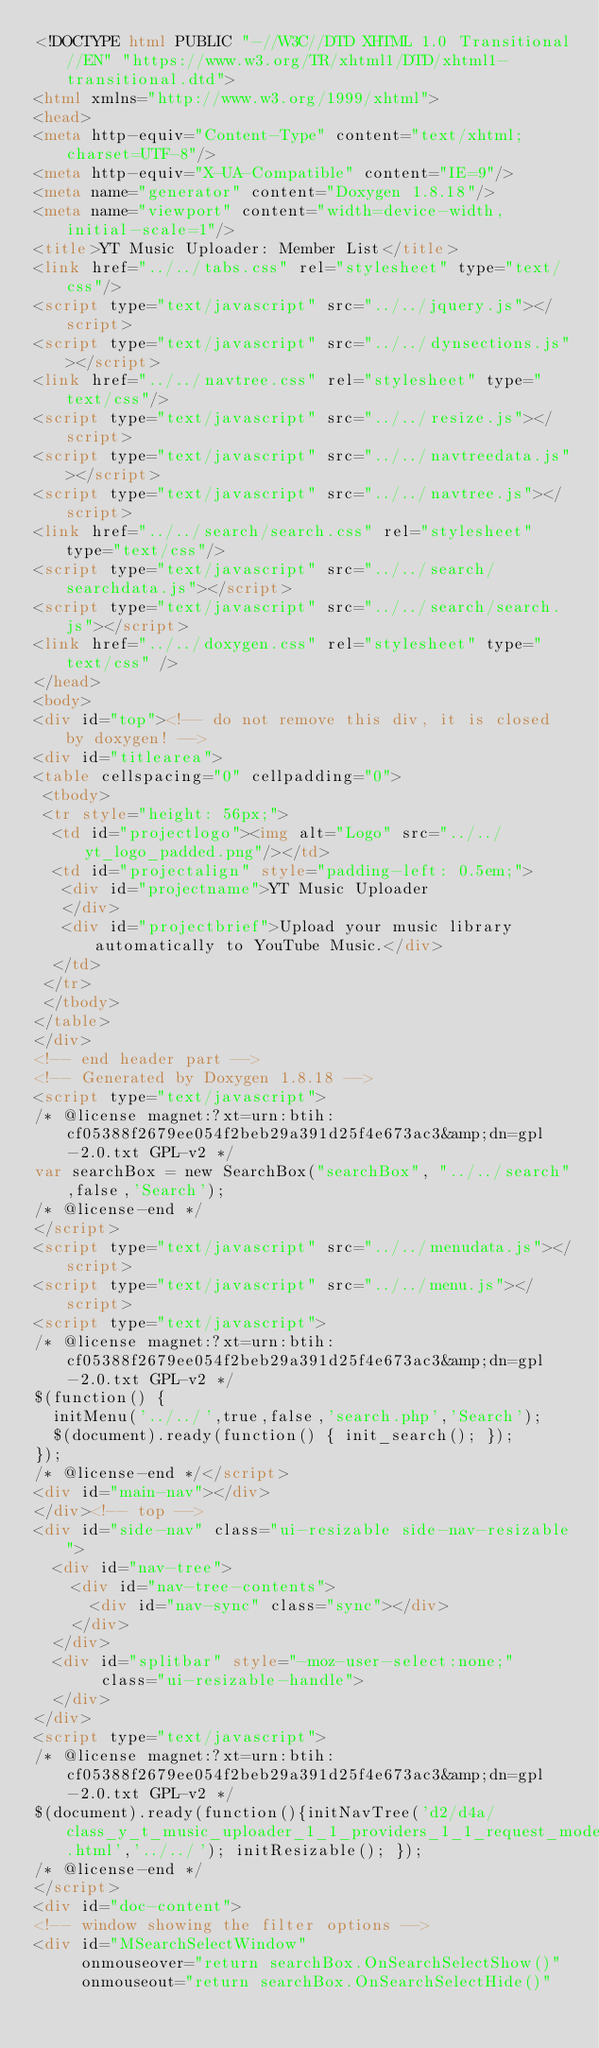Convert code to text. <code><loc_0><loc_0><loc_500><loc_500><_HTML_><!DOCTYPE html PUBLIC "-//W3C//DTD XHTML 1.0 Transitional//EN" "https://www.w3.org/TR/xhtml1/DTD/xhtml1-transitional.dtd">
<html xmlns="http://www.w3.org/1999/xhtml">
<head>
<meta http-equiv="Content-Type" content="text/xhtml;charset=UTF-8"/>
<meta http-equiv="X-UA-Compatible" content="IE=9"/>
<meta name="generator" content="Doxygen 1.8.18"/>
<meta name="viewport" content="width=device-width, initial-scale=1"/>
<title>YT Music Uploader: Member List</title>
<link href="../../tabs.css" rel="stylesheet" type="text/css"/>
<script type="text/javascript" src="../../jquery.js"></script>
<script type="text/javascript" src="../../dynsections.js"></script>
<link href="../../navtree.css" rel="stylesheet" type="text/css"/>
<script type="text/javascript" src="../../resize.js"></script>
<script type="text/javascript" src="../../navtreedata.js"></script>
<script type="text/javascript" src="../../navtree.js"></script>
<link href="../../search/search.css" rel="stylesheet" type="text/css"/>
<script type="text/javascript" src="../../search/searchdata.js"></script>
<script type="text/javascript" src="../../search/search.js"></script>
<link href="../../doxygen.css" rel="stylesheet" type="text/css" />
</head>
<body>
<div id="top"><!-- do not remove this div, it is closed by doxygen! -->
<div id="titlearea">
<table cellspacing="0" cellpadding="0">
 <tbody>
 <tr style="height: 56px;">
  <td id="projectlogo"><img alt="Logo" src="../../yt_logo_padded.png"/></td>
  <td id="projectalign" style="padding-left: 0.5em;">
   <div id="projectname">YT Music Uploader
   </div>
   <div id="projectbrief">Upload your music library automatically to YouTube Music.</div>
  </td>
 </tr>
 </tbody>
</table>
</div>
<!-- end header part -->
<!-- Generated by Doxygen 1.8.18 -->
<script type="text/javascript">
/* @license magnet:?xt=urn:btih:cf05388f2679ee054f2beb29a391d25f4e673ac3&amp;dn=gpl-2.0.txt GPL-v2 */
var searchBox = new SearchBox("searchBox", "../../search",false,'Search');
/* @license-end */
</script>
<script type="text/javascript" src="../../menudata.js"></script>
<script type="text/javascript" src="../../menu.js"></script>
<script type="text/javascript">
/* @license magnet:?xt=urn:btih:cf05388f2679ee054f2beb29a391d25f4e673ac3&amp;dn=gpl-2.0.txt GPL-v2 */
$(function() {
  initMenu('../../',true,false,'search.php','Search');
  $(document).ready(function() { init_search(); });
});
/* @license-end */</script>
<div id="main-nav"></div>
</div><!-- top -->
<div id="side-nav" class="ui-resizable side-nav-resizable">
  <div id="nav-tree">
    <div id="nav-tree-contents">
      <div id="nav-sync" class="sync"></div>
    </div>
  </div>
  <div id="splitbar" style="-moz-user-select:none;" 
       class="ui-resizable-handle">
  </div>
</div>
<script type="text/javascript">
/* @license magnet:?xt=urn:btih:cf05388f2679ee054f2beb29a391d25f4e673ac3&amp;dn=gpl-2.0.txt GPL-v2 */
$(document).ready(function(){initNavTree('d2/d4a/class_y_t_music_uploader_1_1_providers_1_1_request_models_1_1_accessibilitydata7.html','../../'); initResizable(); });
/* @license-end */
</script>
<div id="doc-content">
<!-- window showing the filter options -->
<div id="MSearchSelectWindow"
     onmouseover="return searchBox.OnSearchSelectShow()"
     onmouseout="return searchBox.OnSearchSelectHide()"</code> 